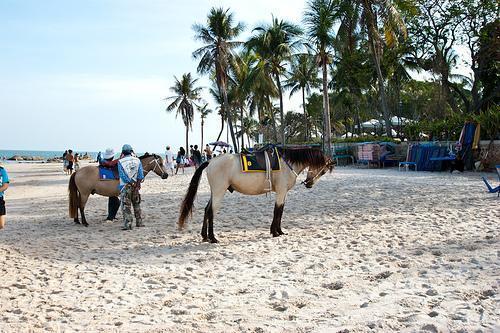How many horses are there?
Give a very brief answer. 2. 